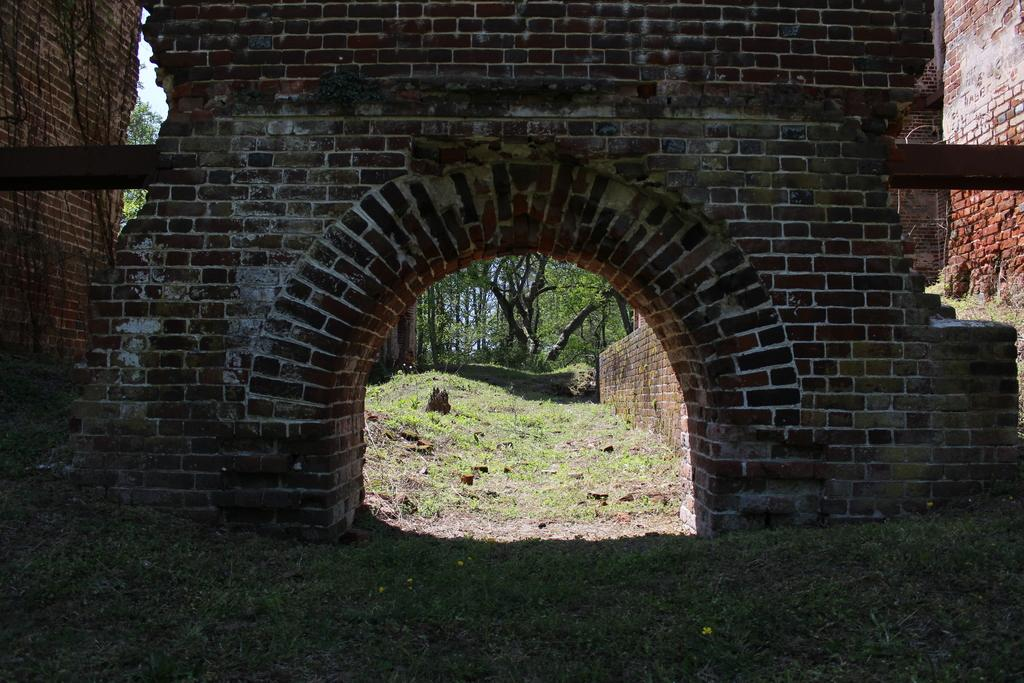What type of structure can be seen in the image? There are brick walls in the image. What type of vegetation is visible in the image? There is grass and trees visible in the image. Where is the volleyball court located in the image? There is no volleyball court present in the image. What type of hook can be seen hanging from the trees in the image? There are no hooks visible in the image, as it only features brick walls, grass, and trees. 